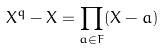Convert formula to latex. <formula><loc_0><loc_0><loc_500><loc_500>X ^ { q } - X = \prod _ { a \in F } ( X - a )</formula> 